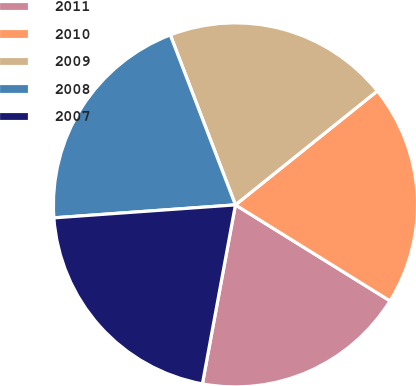Convert chart to OTSL. <chart><loc_0><loc_0><loc_500><loc_500><pie_chart><fcel>2011<fcel>2010<fcel>2009<fcel>2008<fcel>2007<nl><fcel>19.06%<fcel>19.61%<fcel>20.06%<fcel>20.31%<fcel>20.96%<nl></chart> 